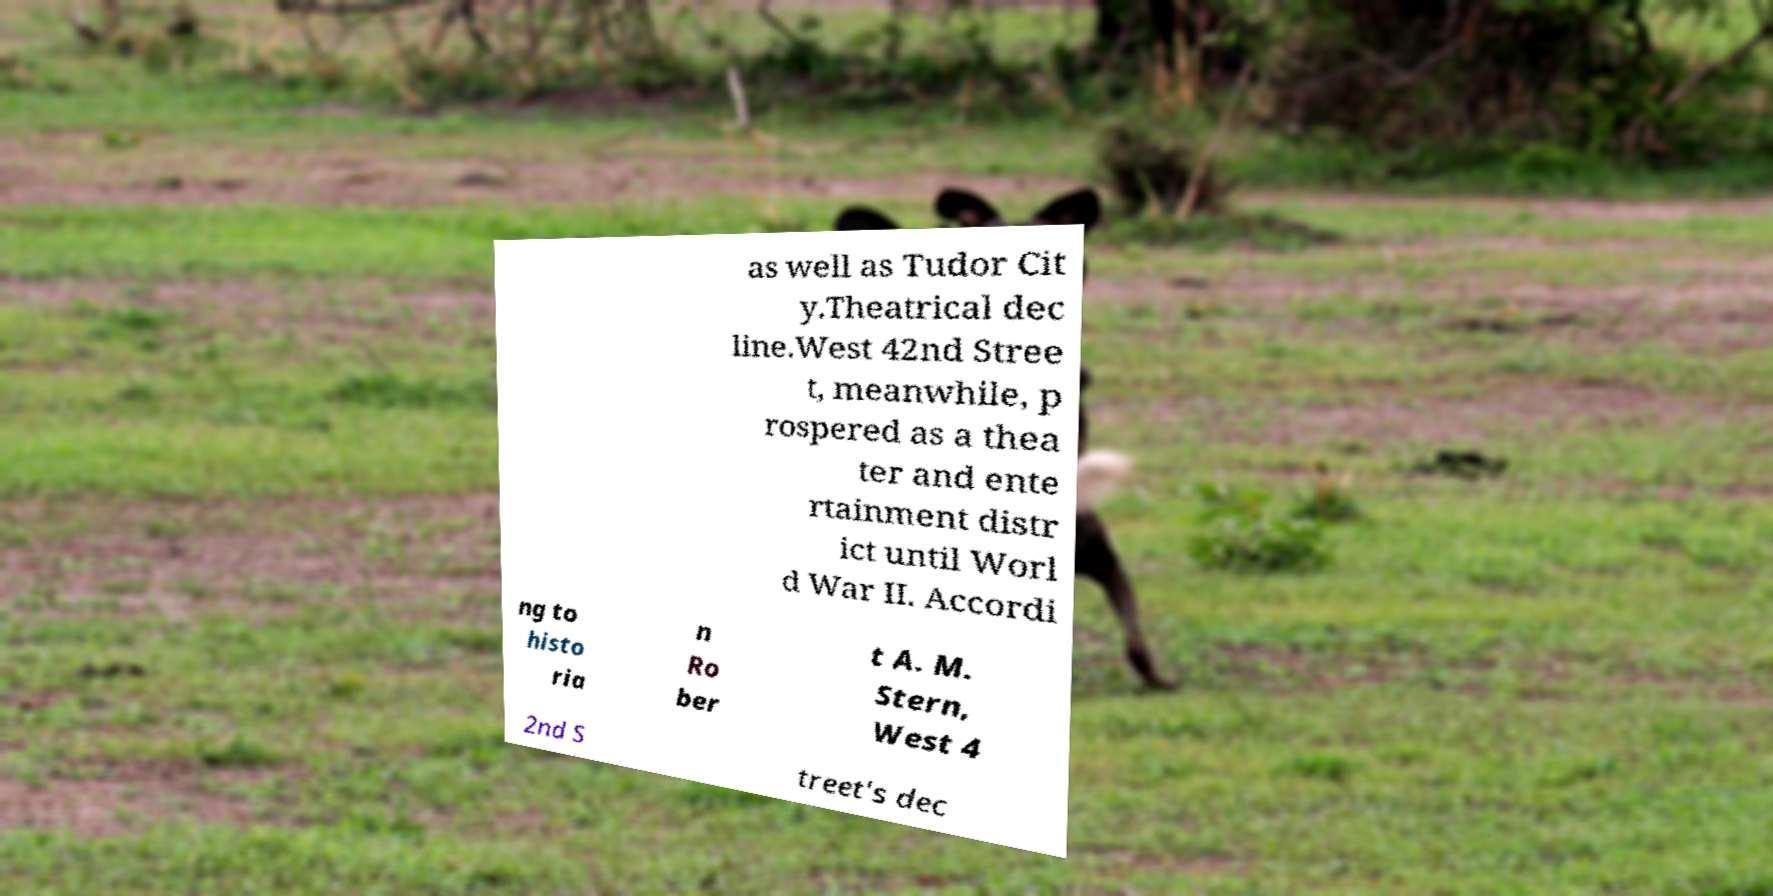There's text embedded in this image that I need extracted. Can you transcribe it verbatim? as well as Tudor Cit y.Theatrical dec line.West 42nd Stree t, meanwhile, p rospered as a thea ter and ente rtainment distr ict until Worl d War II. Accordi ng to histo ria n Ro ber t A. M. Stern, West 4 2nd S treet's dec 